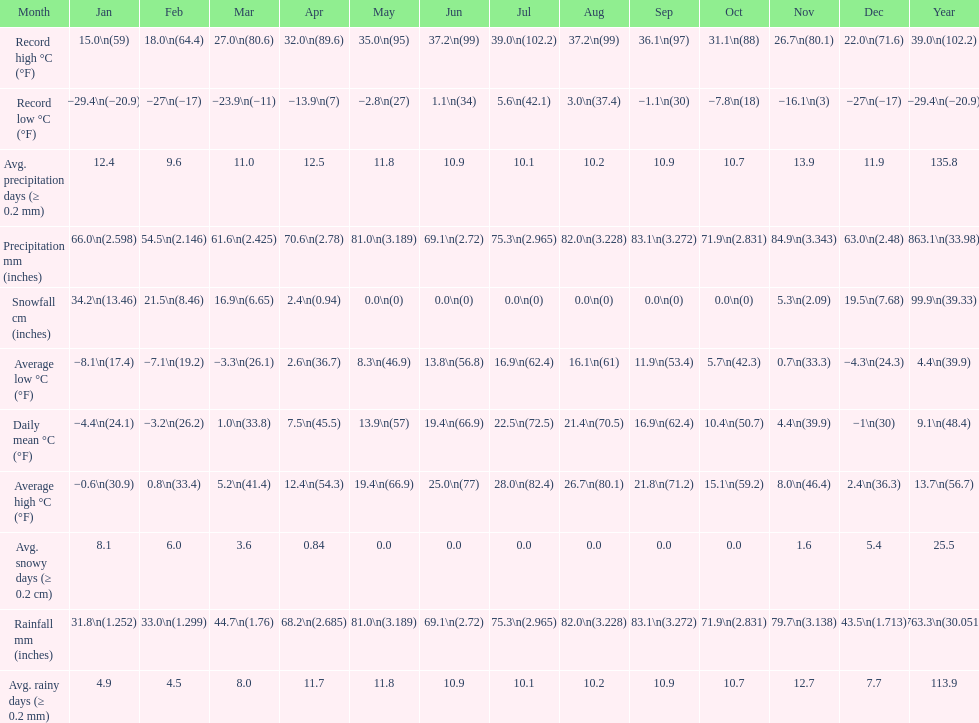Between january, october and december which month had the most rainfall? October. 